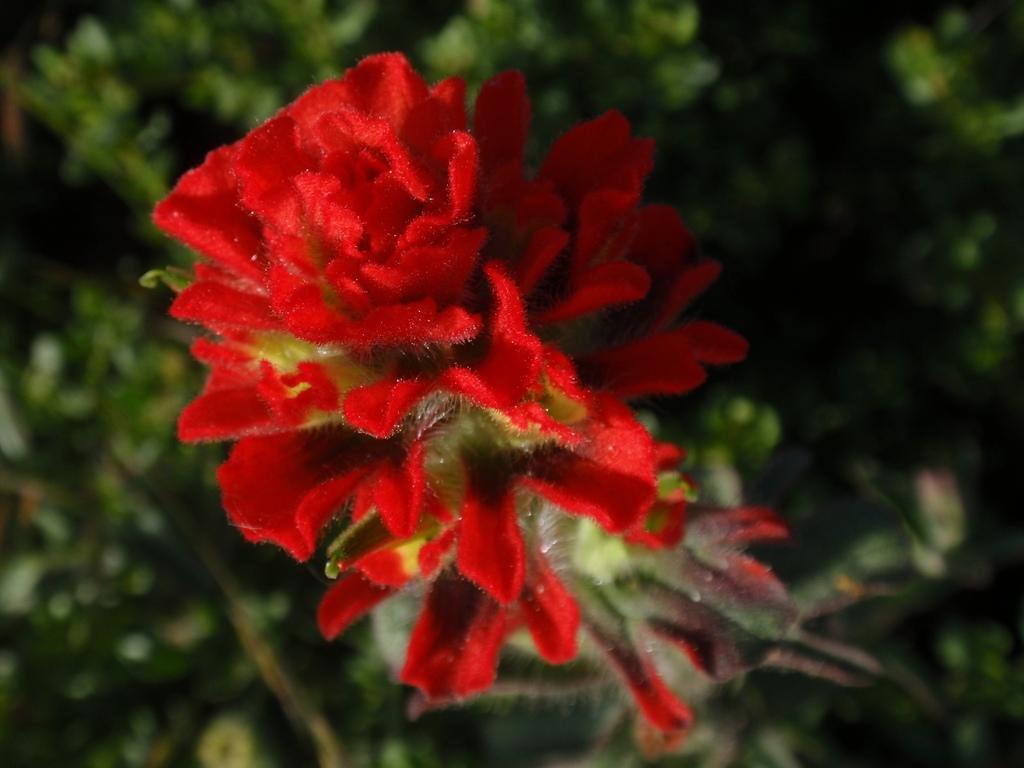Describe this image in one or two sentences. In the center of the image we can see flowers which are in red color. In the background there are plants. 